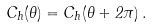<formula> <loc_0><loc_0><loc_500><loc_500>C _ { h } ( \theta ) = C _ { h } ( \theta + 2 \pi ) \, .</formula> 